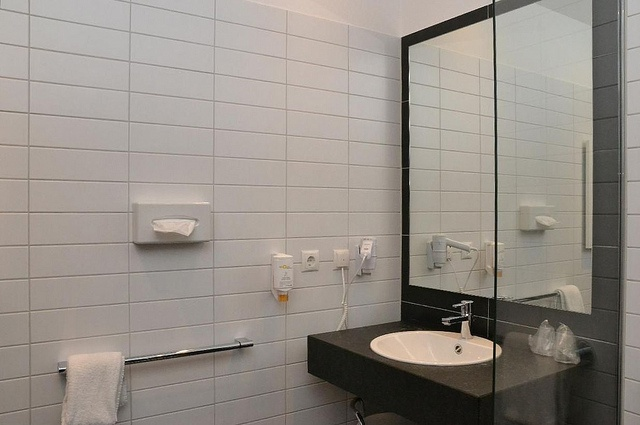Describe the objects in this image and their specific colors. I can see sink in darkgray and tan tones, hair drier in darkgray and gray tones, and hair drier in darkgray, lightgray, and gray tones in this image. 